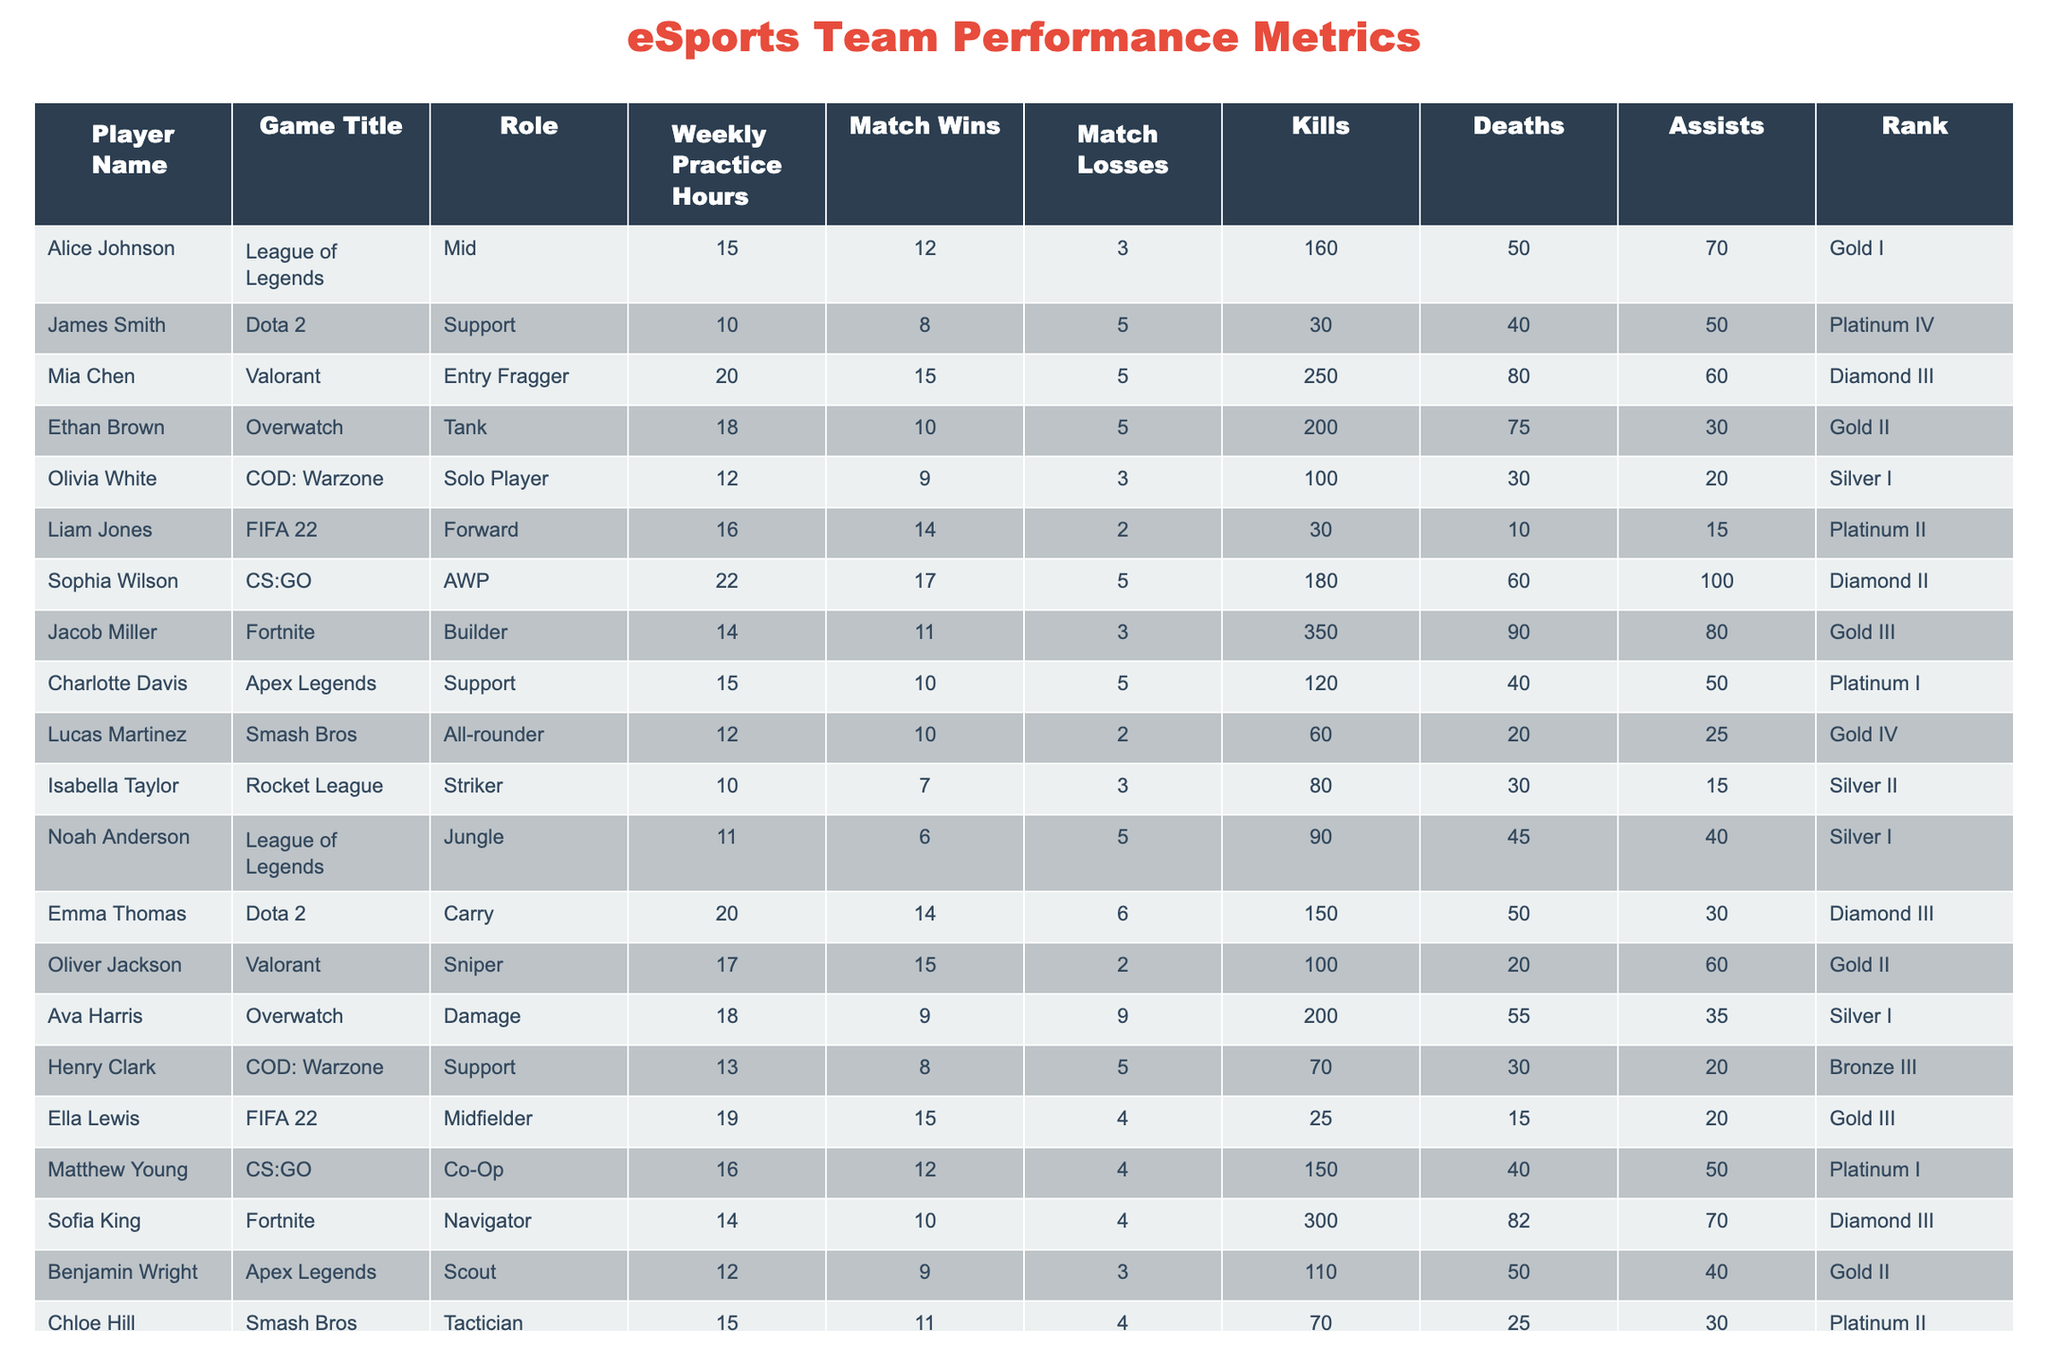What is the player with the highest number of match wins? Looking through the "Match Wins" column, we see that Sophia Wilson has 17 match wins, which is the highest compared to other players.
Answer: Sophia Wilson What is the total number of practice hours for all players combined? We sum up the "Weekly Practice Hours" for all players: 15 + 10 + 20 + 18 + 12 + 16 + 22 + 14 + 15 + 12 + 10 + 11 + 20 + 17 + 18 + 19 + 16 + 14 + 12 + 15 = 354.
Answer: 354 How many players have a rank of Gold or higher? Counting the ranks listed, we find that there are 12 players with ranks of Gold or higher: Gold I, Gold II, Gold III, Platinum I, Platinum II, Platinum IV, Diamond II, Diamond III (4 players each) and someone with Gold IV.
Answer: 12 What is the average kills per player? To find the average kills, we sum the "Kills" column (160 + 30 + 250 + 200 + 100 + 30 + 180 + 350 + 120 + 60 + 80 + 90 + 150 + 100 + 200 + 25 + 150 + 300 + 110 + 70 = 2740) and divide by the number of players (20): 2740 / 20 = 137.
Answer: 137 Is there a player who has a perfect win rate (0 losses)? Checking the "Match Losses" column, no player has 0 losses as the values vary from 2 to 9, indicating that all players have lost at least one match.
Answer: No What is the player with the highest kills/deaths ratio? We calculate the kills/deaths ratio for each player: Alice Johnson (160/50), James Smith (30/40), Mia Chen (250/80), etc. The highest ratio belongs to Mia Chen at 250/80 = 3.125.
Answer: Mia Chen Which player practiced the least number of hours? By reviewing the "Weekly Practice Hours" column, we find the player with the least hours is Isabella Taylor with 10 hours of practice.
Answer: Isabella Taylor How many players have more kills than deaths? Analyzing the "Kills" and "Deaths" columns, we see that 11 players have more kills than deaths, indicating a better performance.
Answer: 11 What is the total number of match losses by the team? We sum the "Match Losses" column for all players: 3 + 5 + 5 + 5 + 3 + 2 + 5 + 3 + 5 + 2 + 3 + 5 + 6 + 2 + 9 + 4 + 4 + 3 + 4 + 4 = 67.
Answer: 67 Who is the top player in terms of assists? By examining the "Assists" column, Olivia White has the highest assists, 20, which is more than anyone else.
Answer: Olivia White 